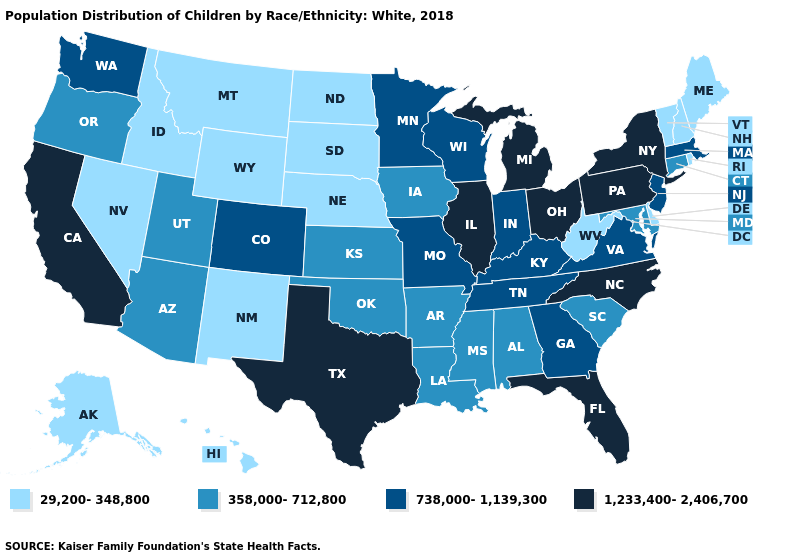Name the states that have a value in the range 738,000-1,139,300?
Concise answer only. Colorado, Georgia, Indiana, Kentucky, Massachusetts, Minnesota, Missouri, New Jersey, Tennessee, Virginia, Washington, Wisconsin. What is the value of California?
Give a very brief answer. 1,233,400-2,406,700. How many symbols are there in the legend?
Give a very brief answer. 4. Does Wyoming have a lower value than Vermont?
Write a very short answer. No. Name the states that have a value in the range 358,000-712,800?
Quick response, please. Alabama, Arizona, Arkansas, Connecticut, Iowa, Kansas, Louisiana, Maryland, Mississippi, Oklahoma, Oregon, South Carolina, Utah. Name the states that have a value in the range 358,000-712,800?
Give a very brief answer. Alabama, Arizona, Arkansas, Connecticut, Iowa, Kansas, Louisiana, Maryland, Mississippi, Oklahoma, Oregon, South Carolina, Utah. Name the states that have a value in the range 29,200-348,800?
Quick response, please. Alaska, Delaware, Hawaii, Idaho, Maine, Montana, Nebraska, Nevada, New Hampshire, New Mexico, North Dakota, Rhode Island, South Dakota, Vermont, West Virginia, Wyoming. Name the states that have a value in the range 29,200-348,800?
Short answer required. Alaska, Delaware, Hawaii, Idaho, Maine, Montana, Nebraska, Nevada, New Hampshire, New Mexico, North Dakota, Rhode Island, South Dakota, Vermont, West Virginia, Wyoming. What is the value of Delaware?
Give a very brief answer. 29,200-348,800. Among the states that border Connecticut , which have the lowest value?
Concise answer only. Rhode Island. What is the lowest value in states that border New Jersey?
Give a very brief answer. 29,200-348,800. How many symbols are there in the legend?
Write a very short answer. 4. Which states have the lowest value in the USA?
Write a very short answer. Alaska, Delaware, Hawaii, Idaho, Maine, Montana, Nebraska, Nevada, New Hampshire, New Mexico, North Dakota, Rhode Island, South Dakota, Vermont, West Virginia, Wyoming. Which states have the lowest value in the Northeast?
Short answer required. Maine, New Hampshire, Rhode Island, Vermont. Which states have the lowest value in the West?
Answer briefly. Alaska, Hawaii, Idaho, Montana, Nevada, New Mexico, Wyoming. 